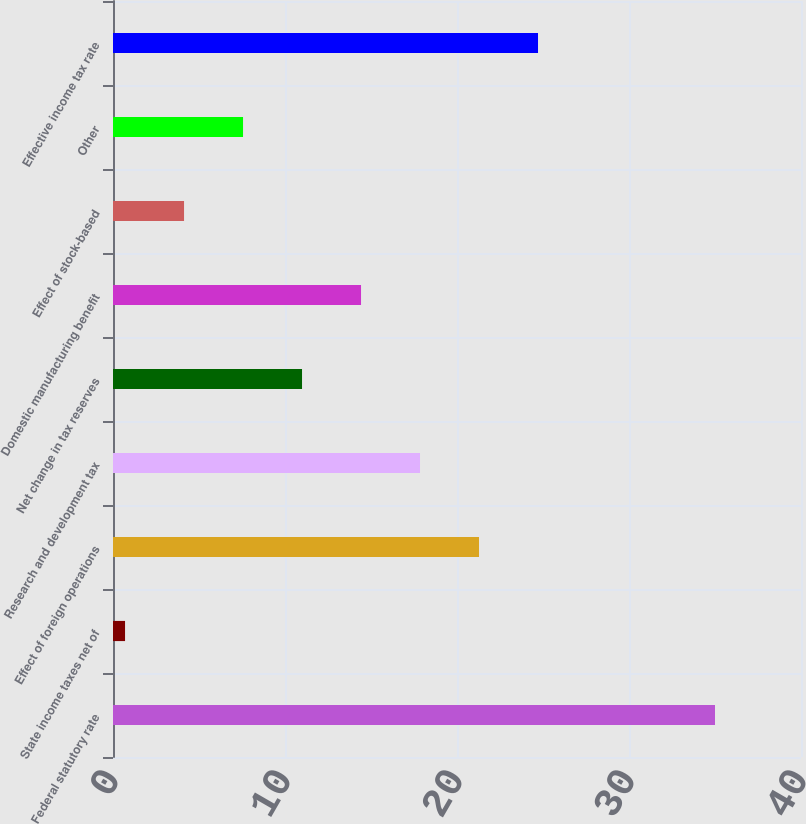<chart> <loc_0><loc_0><loc_500><loc_500><bar_chart><fcel>Federal statutory rate<fcel>State income taxes net of<fcel>Effect of foreign operations<fcel>Research and development tax<fcel>Net change in tax reserves<fcel>Domestic manufacturing benefit<fcel>Effect of stock-based<fcel>Other<fcel>Effective income tax rate<nl><fcel>35<fcel>0.7<fcel>21.28<fcel>17.85<fcel>10.99<fcel>14.42<fcel>4.13<fcel>7.56<fcel>24.71<nl></chart> 